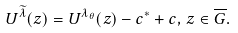Convert formula to latex. <formula><loc_0><loc_0><loc_500><loc_500>U ^ { \widetilde { \lambda } } ( z ) = U ^ { \lambda _ { \theta } } ( z ) - c ^ { * } + c , \, z \in \overline { G } .</formula> 